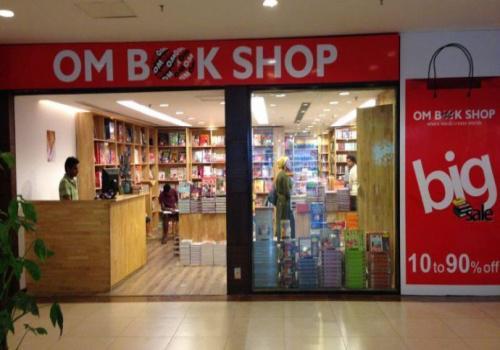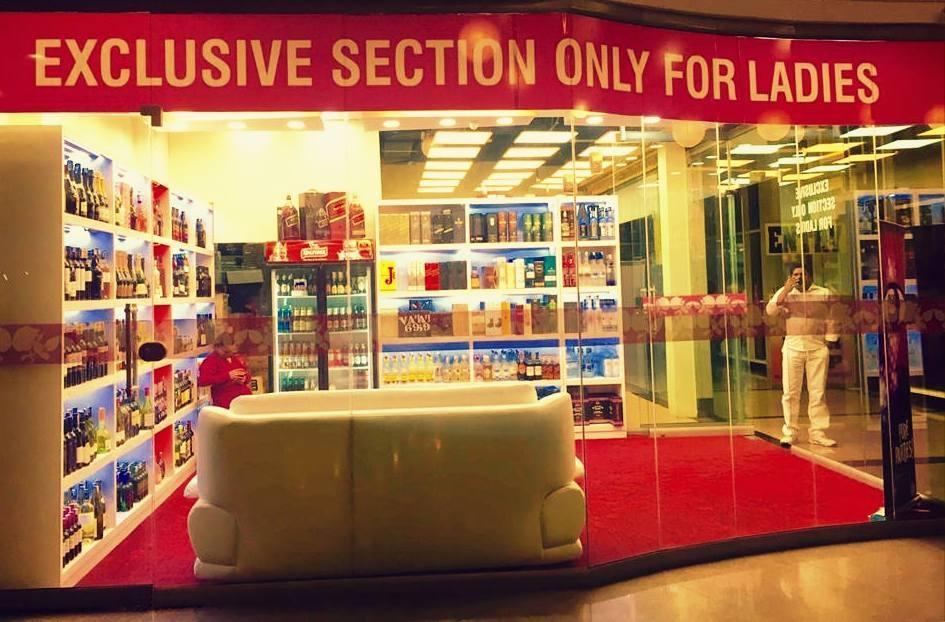The first image is the image on the left, the second image is the image on the right. Examine the images to the left and right. Is the description "In one image, a clerk can be seen to the left behind a counter of a bookstore, bookshelves extending down that wall and across the back, with three customers in the store." accurate? Answer yes or no. Yes. The first image is the image on the left, the second image is the image on the right. For the images displayed, is the sentence "Both images show store exteriors with red-background signs above the entrance." factually correct? Answer yes or no. Yes. 